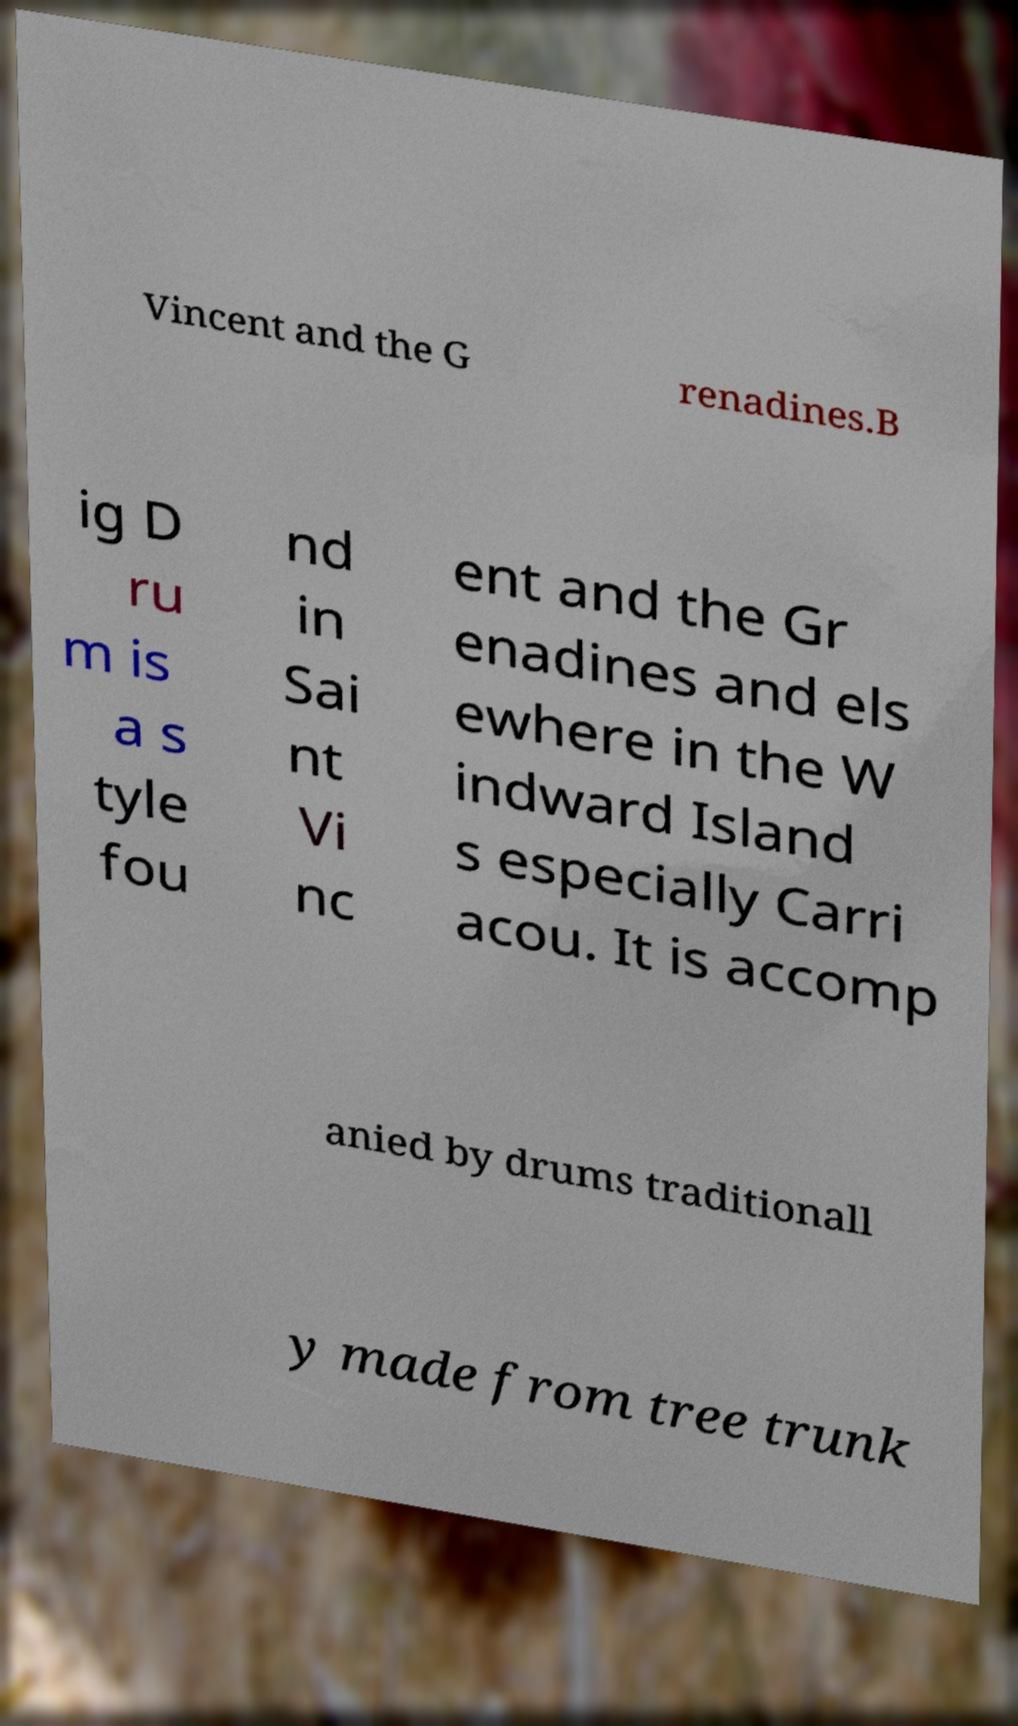Please read and relay the text visible in this image. What does it say? Vincent and the G renadines.B ig D ru m is a s tyle fou nd in Sai nt Vi nc ent and the Gr enadines and els ewhere in the W indward Island s especially Carri acou. It is accomp anied by drums traditionall y made from tree trunk 